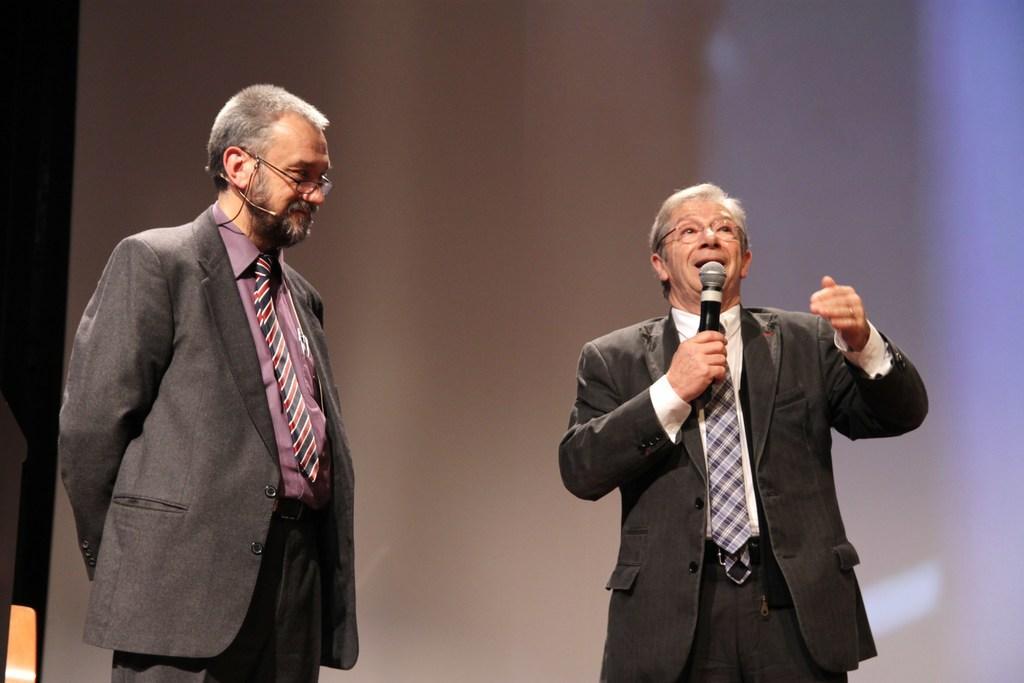In one or two sentences, can you explain what this image depicts? In this picture we can see two person one is listening the speech wearing black coat ,pink shirt and red strip tie. Other is delivering the speech on microphone wearing black coat and specs. 